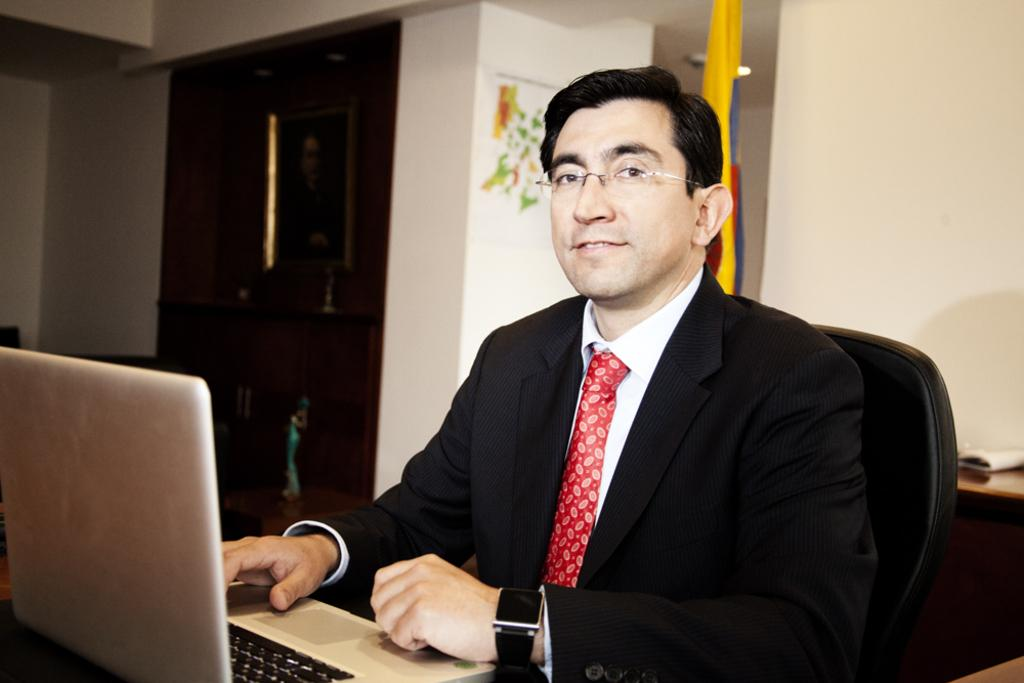What can be seen in the image? There is a person in the image. Can you describe the person's appearance? The person is wearing glasses (specs) and a watch. What is the person doing in the image? The person is sitting on a chair. What object is in front of the person? There is a laptop in front of the person. What can be seen in the background of the image? There is a wall, a flag, and a cupboard in the background of the image. What type of brick is used to build the approval in the image? There is no brick or approval present in the image. What color is the sky in the image? The image does not show the sky, so it cannot be determined from the image. 